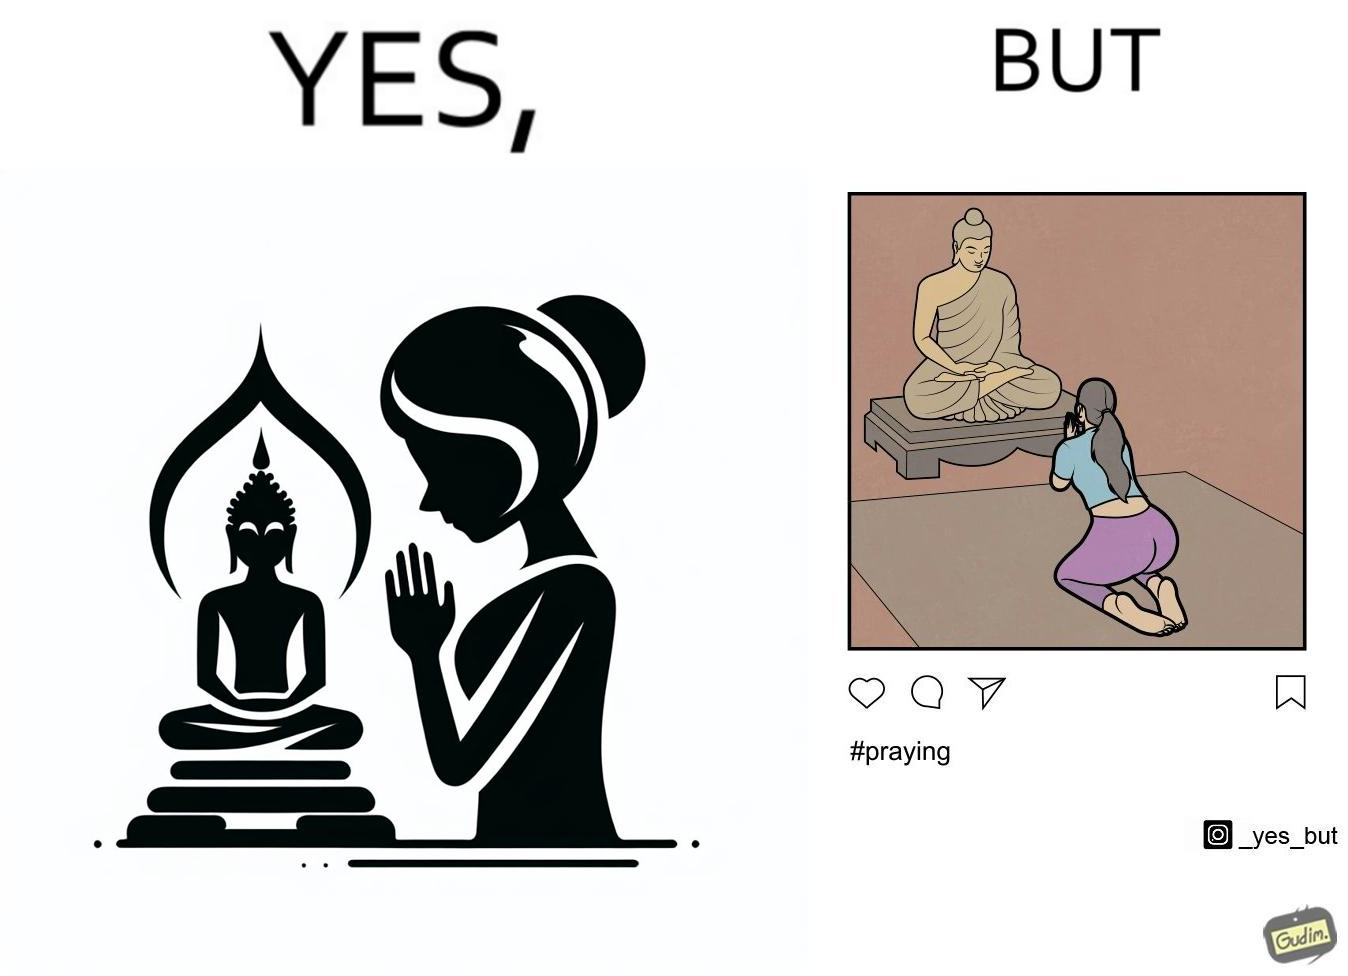What is the satirical meaning behind this image? The image is ironic, because in the first image it seems that the woman is praying whole heartedly by bowing down in front of the statue but in the second image the same image is seen posted on the internet, so the woman was just posing for a photo to be posted on internet to gain followers or likes 